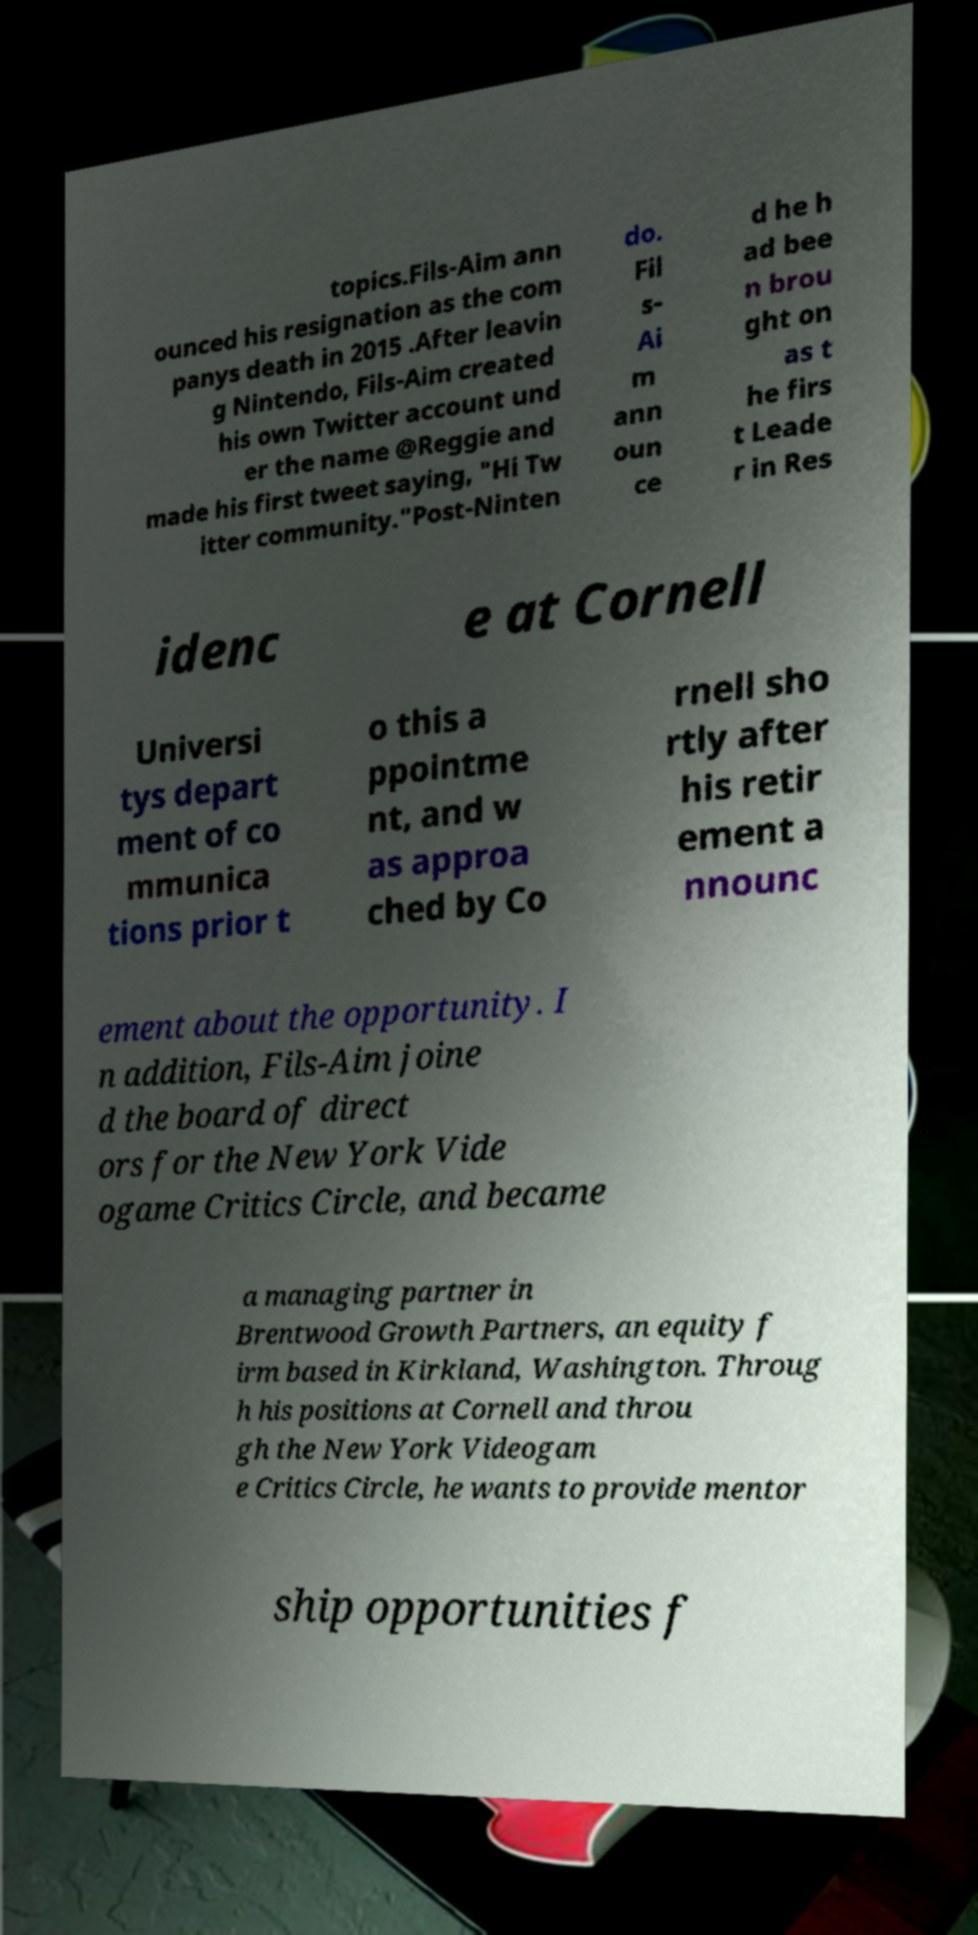For documentation purposes, I need the text within this image transcribed. Could you provide that? topics.Fils-Aim ann ounced his resignation as the com panys death in 2015 .After leavin g Nintendo, Fils-Aim created his own Twitter account und er the name @Reggie and made his first tweet saying, "Hi Tw itter community."Post-Ninten do. Fil s- Ai m ann oun ce d he h ad bee n brou ght on as t he firs t Leade r in Res idenc e at Cornell Universi tys depart ment of co mmunica tions prior t o this a ppointme nt, and w as approa ched by Co rnell sho rtly after his retir ement a nnounc ement about the opportunity. I n addition, Fils-Aim joine d the board of direct ors for the New York Vide ogame Critics Circle, and became a managing partner in Brentwood Growth Partners, an equity f irm based in Kirkland, Washington. Throug h his positions at Cornell and throu gh the New York Videogam e Critics Circle, he wants to provide mentor ship opportunities f 